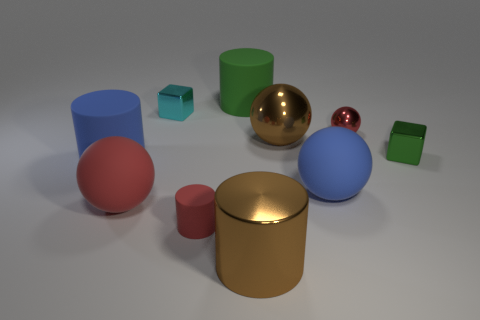What is the material of the green thing that is to the right of the red ball that is behind the rubber cylinder on the left side of the tiny rubber cylinder?
Your answer should be compact. Metal. What number of matte objects are small brown balls or big green cylinders?
Offer a terse response. 1. How many purple objects are either metal cubes or large balls?
Your response must be concise. 0. Does the rubber cylinder on the left side of the tiny red matte cylinder have the same color as the large shiny cylinder?
Offer a very short reply. No. Do the small green block and the small cylinder have the same material?
Offer a terse response. No. Is the number of big brown cylinders that are behind the big red rubber sphere the same as the number of red objects that are in front of the big brown cylinder?
Ensure brevity in your answer.  Yes. There is a cyan thing that is the same shape as the small green object; what material is it?
Provide a short and direct response. Metal. The brown object that is behind the big sphere on the left side of the green object that is on the left side of the small red metallic object is what shape?
Your answer should be compact. Sphere. Are there more red metallic objects that are on the left side of the blue matte cylinder than gray matte objects?
Provide a succinct answer. No. There is a tiny red object that is behind the brown shiny sphere; is its shape the same as the tiny rubber thing?
Provide a succinct answer. No. 